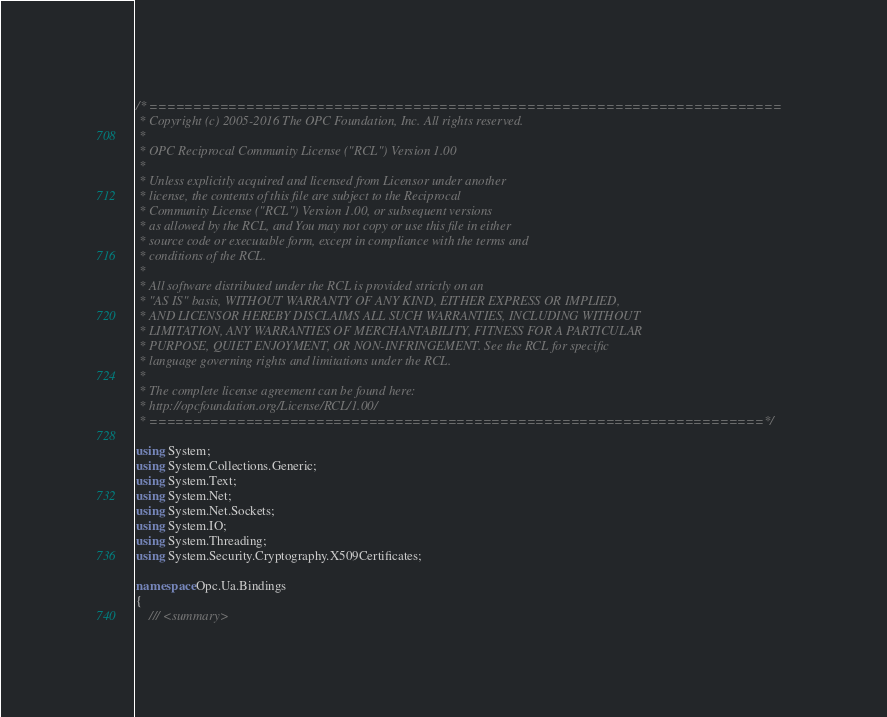<code> <loc_0><loc_0><loc_500><loc_500><_C#_>/* ========================================================================
 * Copyright (c) 2005-2016 The OPC Foundation, Inc. All rights reserved.
 *
 * OPC Reciprocal Community License ("RCL") Version 1.00
 *
 * Unless explicitly acquired and licensed from Licensor under another
 * license, the contents of this file are subject to the Reciprocal
 * Community License ("RCL") Version 1.00, or subsequent versions
 * as allowed by the RCL, and You may not copy or use this file in either
 * source code or executable form, except in compliance with the terms and
 * conditions of the RCL.
 *
 * All software distributed under the RCL is provided strictly on an
 * "AS IS" basis, WITHOUT WARRANTY OF ANY KIND, EITHER EXPRESS OR IMPLIED,
 * AND LICENSOR HEREBY DISCLAIMS ALL SUCH WARRANTIES, INCLUDING WITHOUT
 * LIMITATION, ANY WARRANTIES OF MERCHANTABILITY, FITNESS FOR A PARTICULAR
 * PURPOSE, QUIET ENJOYMENT, OR NON-INFRINGEMENT. See the RCL for specific
 * language governing rights and limitations under the RCL.
 *
 * The complete license agreement can be found here:
 * http://opcfoundation.org/License/RCL/1.00/
 * ======================================================================*/

using System;
using System.Collections.Generic;
using System.Text;
using System.Net;
using System.Net.Sockets;
using System.IO;
using System.Threading;
using System.Security.Cryptography.X509Certificates;

namespace Opc.Ua.Bindings
{
    /// <summary></code> 